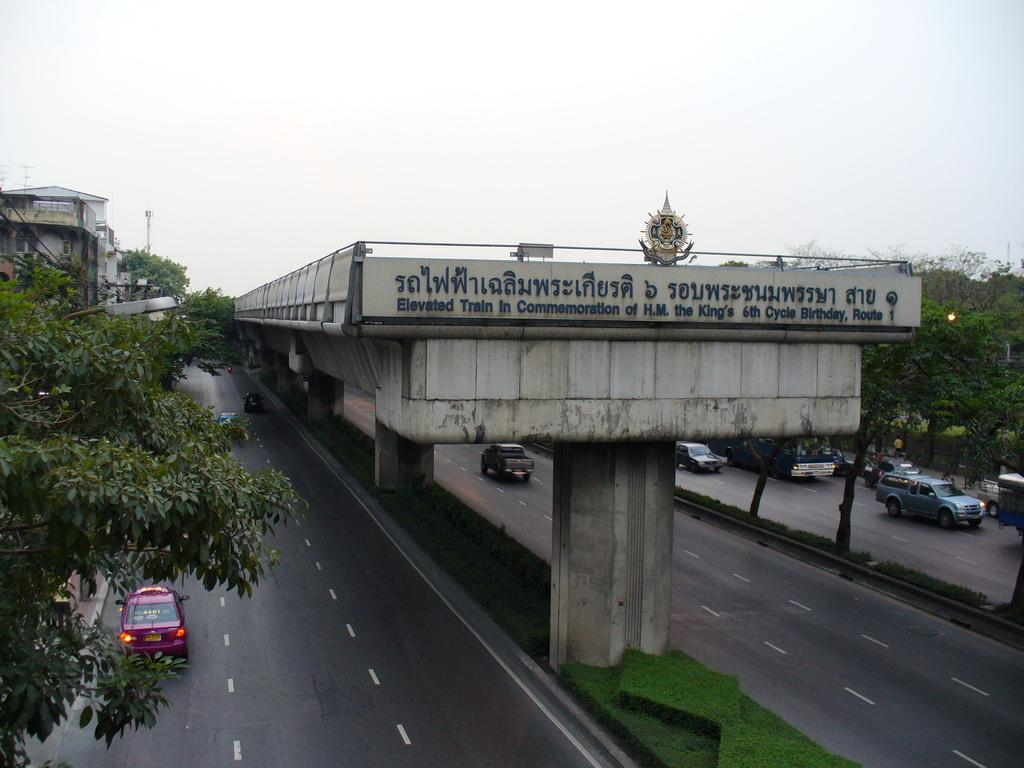What structure is in the middle of the road in the image? There is a bridge in the middle of the road in the image. What type of terrain surrounds the road? The road is on grassland. What can be seen on the road near the bridge? Cars are moving on the road on either side of the bridge. What type of vegetation is present at the corners of the grassland? There are trees at the corners of the grassland. What is visible above the bridge? The sky is visible above the bridge. What type of net is being used to catch the cars on the road in the image? There is no net present in the image, and cars are not being caught; they are moving on the road. 